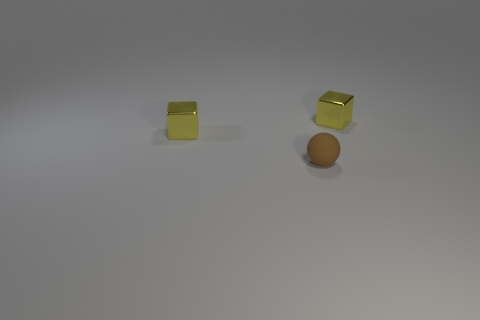Is there any indication of what time of day or setting this could be? The image does not provide direct indicators of the time of day or specific setting due to its neutral background and studio-like lighting. 